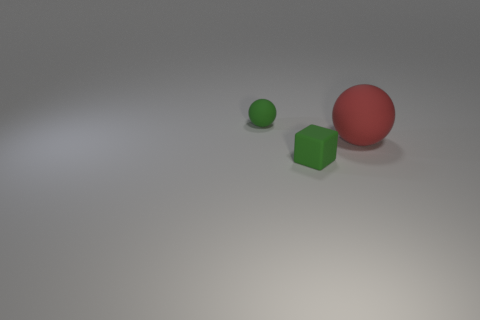Add 1 cyan metallic cylinders. How many objects exist? 4 Subtract all cubes. How many objects are left? 2 Subtract all large gray matte blocks. Subtract all matte spheres. How many objects are left? 1 Add 3 green rubber cubes. How many green rubber cubes are left? 4 Add 2 large brown things. How many large brown things exist? 2 Subtract 0 purple balls. How many objects are left? 3 